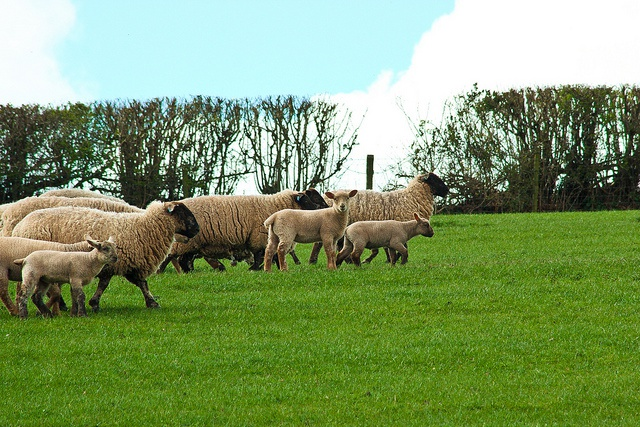Describe the objects in this image and their specific colors. I can see sheep in white, black, tan, olive, and gray tones, sheep in white, black, gray, and tan tones, sheep in white, black, darkgreen, gray, and tan tones, sheep in white, gray, and tan tones, and sheep in white, tan, black, olive, and gray tones in this image. 